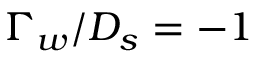<formula> <loc_0><loc_0><loc_500><loc_500>\Gamma _ { w } / D _ { s } = - 1</formula> 